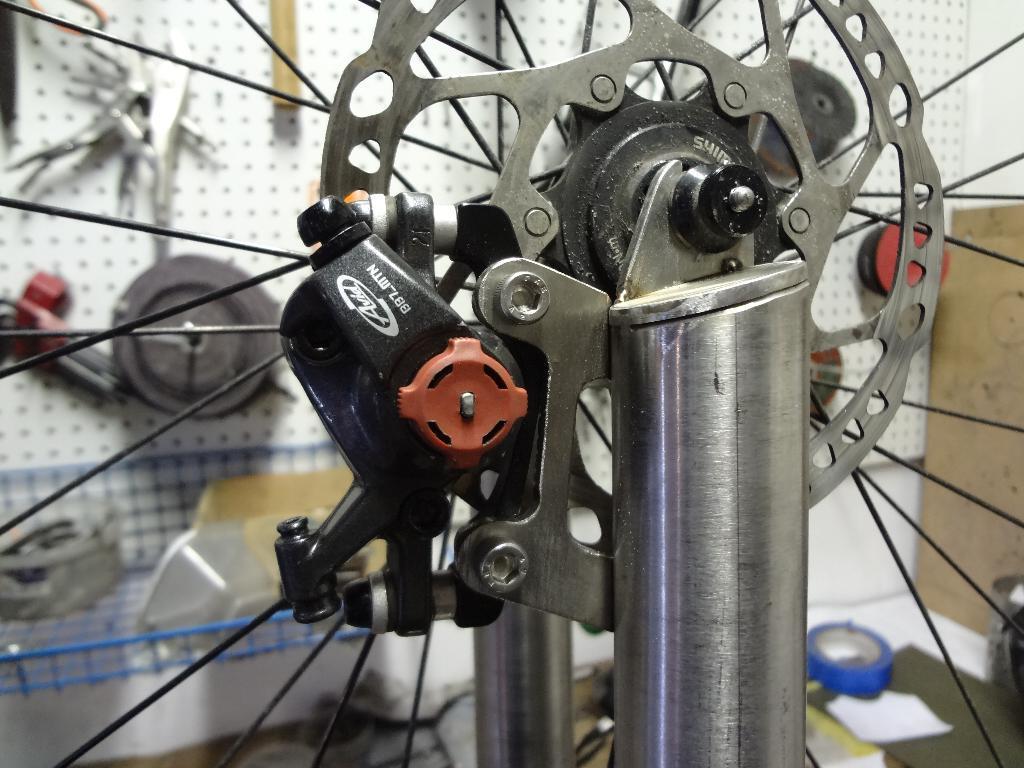In one or two sentences, can you explain what this image depicts? In this image I can see a mechanical instrument and that looks like a hub gear. In the background there are some other objects and there is a wall. 